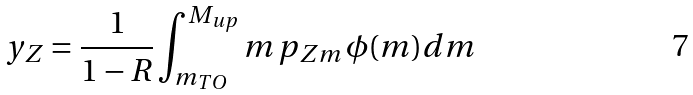<formula> <loc_0><loc_0><loc_500><loc_500>y _ { Z } = \frac { 1 } { 1 - R } \int _ { m _ { T O } } ^ { M _ { u p } } m \, p _ { Z m } \, \phi ( m ) d m</formula> 